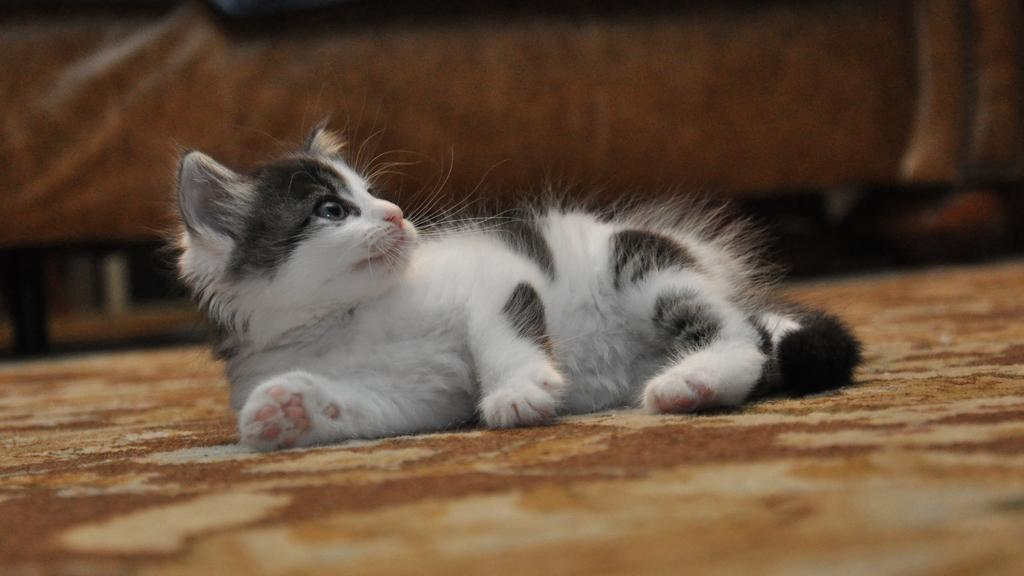What animal is present in the image? There is a cat in the image. What is the cat doing in the image? The cat is laying on the ground. In which direction is the cat looking? The cat is looking to the right side. Can you describe the background of the image? The background of the image is blurred. What type of iron is the cat using in the image? There is no iron present in the image; it features a cat laying on the ground and looking to the right side. Is the cat wearing a collar in the image? The image does not show the cat wearing a collar. 